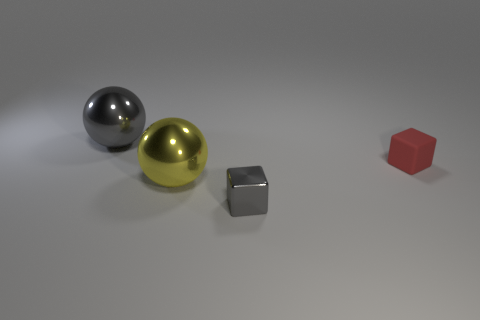Subtract all blue blocks. Subtract all blue cylinders. How many blocks are left? 2 Add 3 gray shiny cubes. How many objects exist? 7 Subtract all big red objects. Subtract all metal spheres. How many objects are left? 2 Add 1 gray cubes. How many gray cubes are left? 2 Add 4 small gray blocks. How many small gray blocks exist? 5 Subtract 1 gray cubes. How many objects are left? 3 